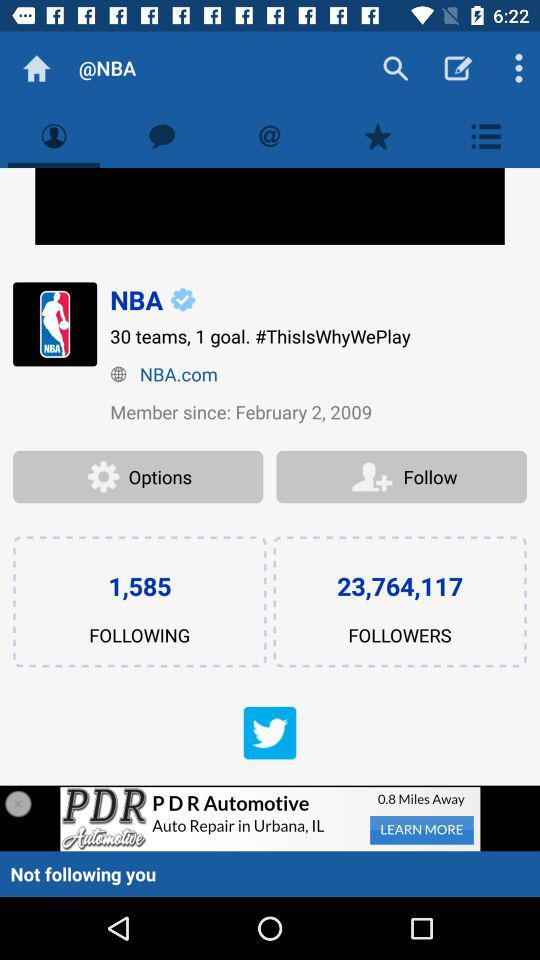When did the NBA become a member? The NBA became a member on February 2, 2009. 